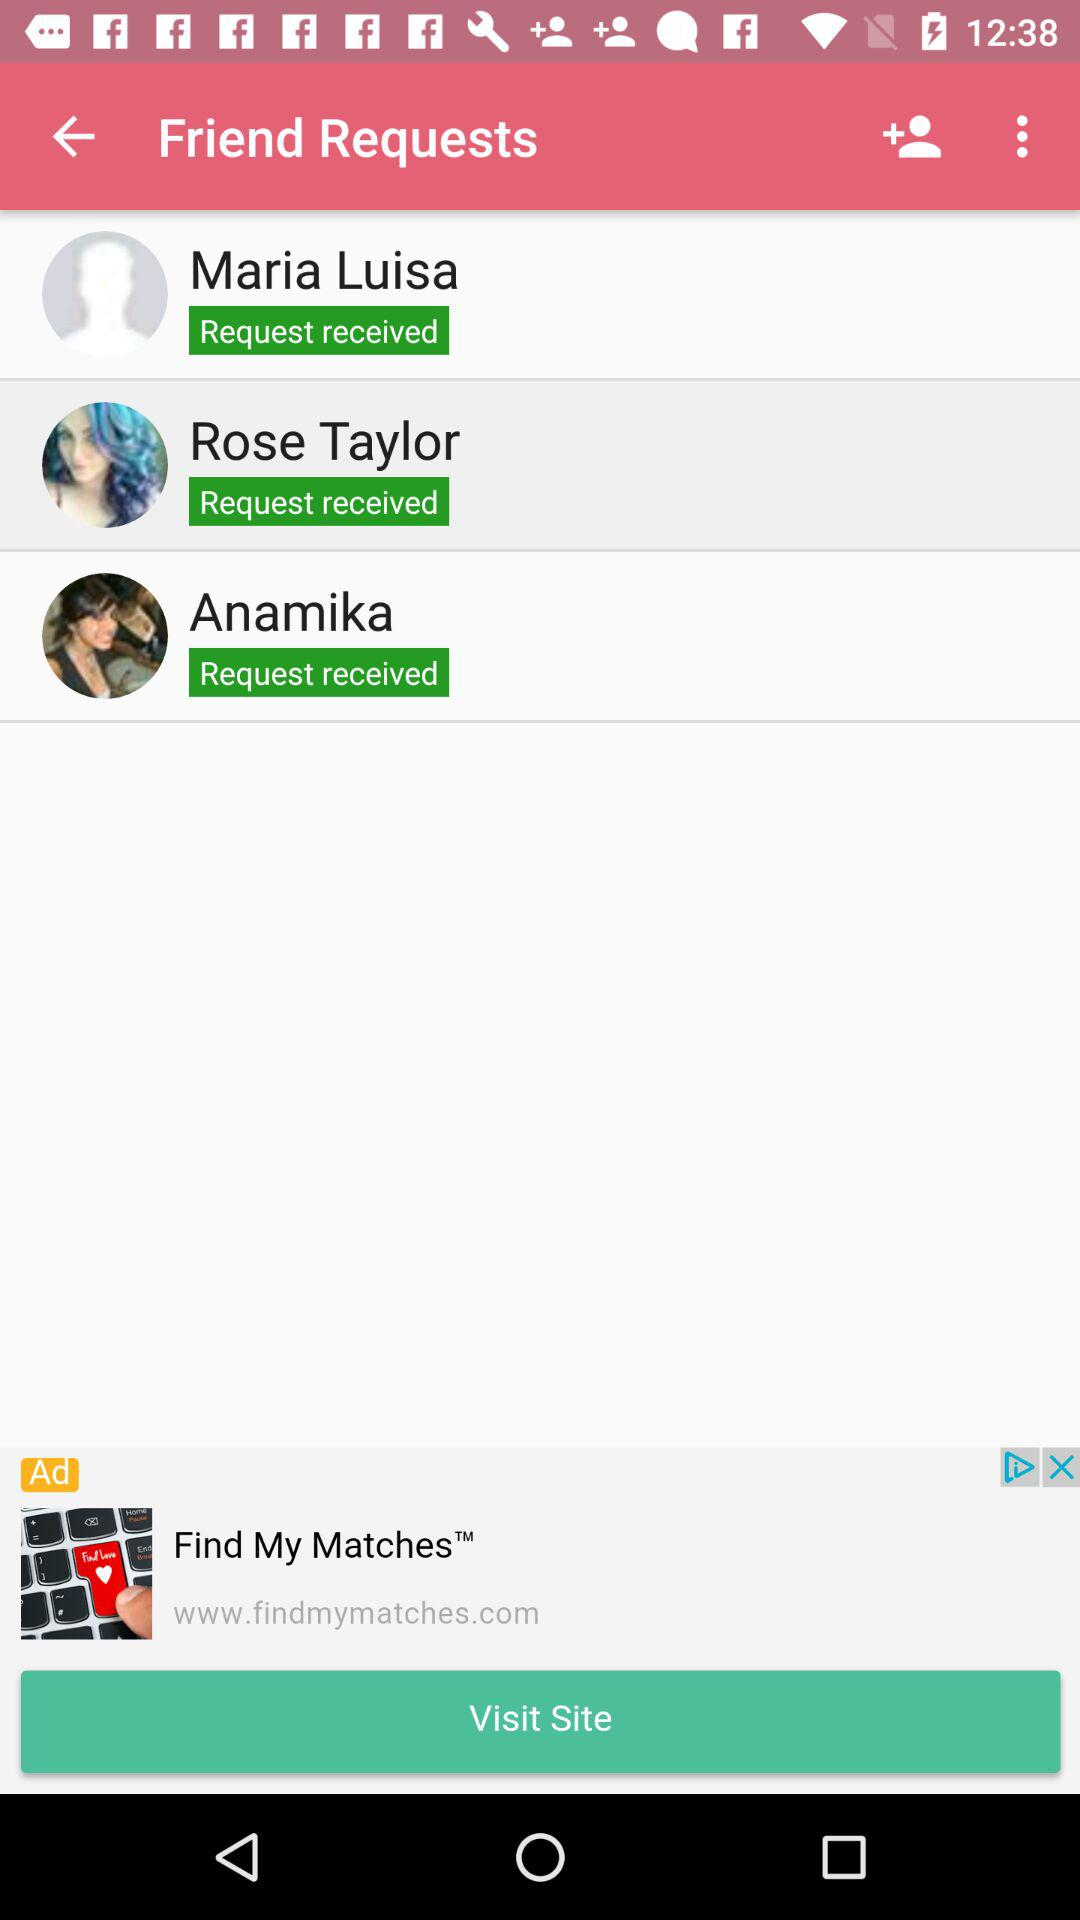How many friend requests do I have?
Answer the question using a single word or phrase. 3 